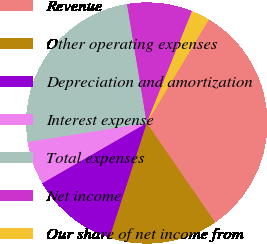Convert chart to OTSL. <chart><loc_0><loc_0><loc_500><loc_500><pie_chart><fcel>Revenue<fcel>Other operating expenses<fcel>Depreciation and amortization<fcel>Interest expense<fcel>Total expenses<fcel>Net income<fcel>Our share of net income from<nl><fcel>31.81%<fcel>14.6%<fcel>11.67%<fcel>5.8%<fcel>24.91%<fcel>8.74%<fcel>2.47%<nl></chart> 